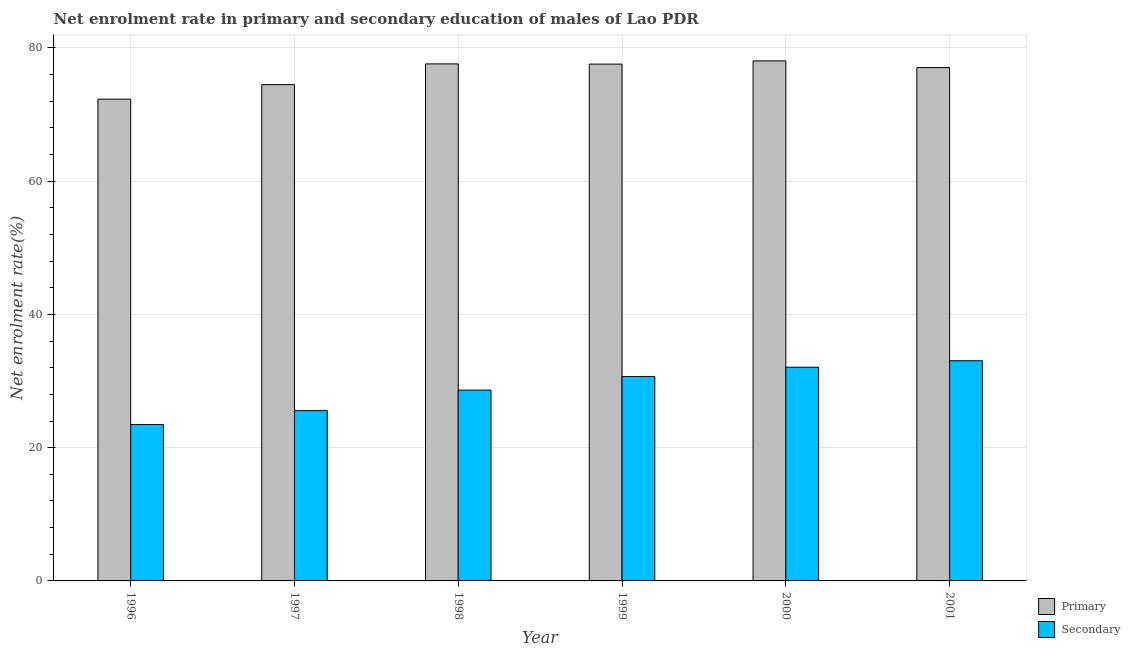Are the number of bars on each tick of the X-axis equal?
Keep it short and to the point. Yes. How many bars are there on the 4th tick from the right?
Your response must be concise. 2. In how many cases, is the number of bars for a given year not equal to the number of legend labels?
Make the answer very short. 0. What is the enrollment rate in primary education in 2000?
Offer a very short reply. 78.07. Across all years, what is the maximum enrollment rate in primary education?
Offer a terse response. 78.07. Across all years, what is the minimum enrollment rate in secondary education?
Provide a short and direct response. 23.48. In which year was the enrollment rate in primary education maximum?
Make the answer very short. 2000. In which year was the enrollment rate in secondary education minimum?
Keep it short and to the point. 1996. What is the total enrollment rate in secondary education in the graph?
Your response must be concise. 173.5. What is the difference between the enrollment rate in secondary education in 1997 and that in 1999?
Offer a very short reply. -5.12. What is the difference between the enrollment rate in primary education in 1998 and the enrollment rate in secondary education in 2000?
Provide a succinct answer. -0.45. What is the average enrollment rate in primary education per year?
Provide a short and direct response. 76.19. In the year 2000, what is the difference between the enrollment rate in primary education and enrollment rate in secondary education?
Your answer should be compact. 0. What is the ratio of the enrollment rate in primary education in 1998 to that in 2000?
Your response must be concise. 0.99. Is the difference between the enrollment rate in primary education in 1996 and 1997 greater than the difference between the enrollment rate in secondary education in 1996 and 1997?
Provide a short and direct response. No. What is the difference between the highest and the second highest enrollment rate in primary education?
Offer a very short reply. 0.45. What is the difference between the highest and the lowest enrollment rate in secondary education?
Your answer should be very brief. 9.57. What does the 2nd bar from the left in 2000 represents?
Provide a short and direct response. Secondary. What does the 1st bar from the right in 1997 represents?
Your response must be concise. Secondary. How many bars are there?
Keep it short and to the point. 12. Are all the bars in the graph horizontal?
Keep it short and to the point. No. How many years are there in the graph?
Offer a very short reply. 6. What is the difference between two consecutive major ticks on the Y-axis?
Provide a short and direct response. 20. Does the graph contain any zero values?
Your answer should be very brief. No. Where does the legend appear in the graph?
Offer a terse response. Bottom right. How many legend labels are there?
Give a very brief answer. 2. What is the title of the graph?
Your response must be concise. Net enrolment rate in primary and secondary education of males of Lao PDR. What is the label or title of the X-axis?
Offer a very short reply. Year. What is the label or title of the Y-axis?
Your answer should be very brief. Net enrolment rate(%). What is the Net enrolment rate(%) in Primary in 1996?
Your answer should be very brief. 72.32. What is the Net enrolment rate(%) in Secondary in 1996?
Make the answer very short. 23.48. What is the Net enrolment rate(%) in Primary in 1997?
Provide a succinct answer. 74.5. What is the Net enrolment rate(%) of Secondary in 1997?
Make the answer very short. 25.56. What is the Net enrolment rate(%) in Primary in 1998?
Keep it short and to the point. 77.61. What is the Net enrolment rate(%) of Secondary in 1998?
Offer a terse response. 28.64. What is the Net enrolment rate(%) in Primary in 1999?
Your answer should be compact. 77.58. What is the Net enrolment rate(%) in Secondary in 1999?
Provide a short and direct response. 30.68. What is the Net enrolment rate(%) of Primary in 2000?
Keep it short and to the point. 78.07. What is the Net enrolment rate(%) of Secondary in 2000?
Your response must be concise. 32.08. What is the Net enrolment rate(%) of Primary in 2001?
Provide a short and direct response. 77.06. What is the Net enrolment rate(%) of Secondary in 2001?
Offer a very short reply. 33.05. Across all years, what is the maximum Net enrolment rate(%) in Primary?
Ensure brevity in your answer.  78.07. Across all years, what is the maximum Net enrolment rate(%) of Secondary?
Your answer should be very brief. 33.05. Across all years, what is the minimum Net enrolment rate(%) in Primary?
Provide a succinct answer. 72.32. Across all years, what is the minimum Net enrolment rate(%) in Secondary?
Make the answer very short. 23.48. What is the total Net enrolment rate(%) of Primary in the graph?
Offer a terse response. 457.14. What is the total Net enrolment rate(%) in Secondary in the graph?
Give a very brief answer. 173.5. What is the difference between the Net enrolment rate(%) of Primary in 1996 and that in 1997?
Your answer should be compact. -2.18. What is the difference between the Net enrolment rate(%) of Secondary in 1996 and that in 1997?
Your response must be concise. -2.08. What is the difference between the Net enrolment rate(%) of Primary in 1996 and that in 1998?
Provide a short and direct response. -5.29. What is the difference between the Net enrolment rate(%) of Secondary in 1996 and that in 1998?
Give a very brief answer. -5.16. What is the difference between the Net enrolment rate(%) of Primary in 1996 and that in 1999?
Your answer should be compact. -5.26. What is the difference between the Net enrolment rate(%) in Secondary in 1996 and that in 1999?
Offer a terse response. -7.2. What is the difference between the Net enrolment rate(%) of Primary in 1996 and that in 2000?
Ensure brevity in your answer.  -5.75. What is the difference between the Net enrolment rate(%) in Secondary in 1996 and that in 2000?
Your response must be concise. -8.6. What is the difference between the Net enrolment rate(%) in Primary in 1996 and that in 2001?
Your response must be concise. -4.74. What is the difference between the Net enrolment rate(%) in Secondary in 1996 and that in 2001?
Offer a very short reply. -9.57. What is the difference between the Net enrolment rate(%) of Primary in 1997 and that in 1998?
Provide a succinct answer. -3.11. What is the difference between the Net enrolment rate(%) of Secondary in 1997 and that in 1998?
Your answer should be compact. -3.08. What is the difference between the Net enrolment rate(%) in Primary in 1997 and that in 1999?
Provide a succinct answer. -3.08. What is the difference between the Net enrolment rate(%) of Secondary in 1997 and that in 1999?
Offer a terse response. -5.12. What is the difference between the Net enrolment rate(%) in Primary in 1997 and that in 2000?
Provide a succinct answer. -3.56. What is the difference between the Net enrolment rate(%) in Secondary in 1997 and that in 2000?
Offer a very short reply. -6.52. What is the difference between the Net enrolment rate(%) in Primary in 1997 and that in 2001?
Your answer should be compact. -2.56. What is the difference between the Net enrolment rate(%) in Secondary in 1997 and that in 2001?
Keep it short and to the point. -7.49. What is the difference between the Net enrolment rate(%) of Primary in 1998 and that in 1999?
Offer a very short reply. 0.03. What is the difference between the Net enrolment rate(%) of Secondary in 1998 and that in 1999?
Your answer should be very brief. -2.04. What is the difference between the Net enrolment rate(%) in Primary in 1998 and that in 2000?
Ensure brevity in your answer.  -0.45. What is the difference between the Net enrolment rate(%) of Secondary in 1998 and that in 2000?
Ensure brevity in your answer.  -3.44. What is the difference between the Net enrolment rate(%) of Primary in 1998 and that in 2001?
Ensure brevity in your answer.  0.55. What is the difference between the Net enrolment rate(%) of Secondary in 1998 and that in 2001?
Give a very brief answer. -4.41. What is the difference between the Net enrolment rate(%) in Primary in 1999 and that in 2000?
Your answer should be very brief. -0.48. What is the difference between the Net enrolment rate(%) in Secondary in 1999 and that in 2000?
Your answer should be very brief. -1.4. What is the difference between the Net enrolment rate(%) of Primary in 1999 and that in 2001?
Provide a short and direct response. 0.52. What is the difference between the Net enrolment rate(%) in Secondary in 1999 and that in 2001?
Your answer should be compact. -2.37. What is the difference between the Net enrolment rate(%) of Primary in 2000 and that in 2001?
Keep it short and to the point. 1.01. What is the difference between the Net enrolment rate(%) in Secondary in 2000 and that in 2001?
Your answer should be very brief. -0.97. What is the difference between the Net enrolment rate(%) in Primary in 1996 and the Net enrolment rate(%) in Secondary in 1997?
Offer a very short reply. 46.76. What is the difference between the Net enrolment rate(%) of Primary in 1996 and the Net enrolment rate(%) of Secondary in 1998?
Keep it short and to the point. 43.68. What is the difference between the Net enrolment rate(%) in Primary in 1996 and the Net enrolment rate(%) in Secondary in 1999?
Ensure brevity in your answer.  41.64. What is the difference between the Net enrolment rate(%) in Primary in 1996 and the Net enrolment rate(%) in Secondary in 2000?
Give a very brief answer. 40.24. What is the difference between the Net enrolment rate(%) in Primary in 1996 and the Net enrolment rate(%) in Secondary in 2001?
Give a very brief answer. 39.27. What is the difference between the Net enrolment rate(%) of Primary in 1997 and the Net enrolment rate(%) of Secondary in 1998?
Your answer should be compact. 45.86. What is the difference between the Net enrolment rate(%) of Primary in 1997 and the Net enrolment rate(%) of Secondary in 1999?
Offer a terse response. 43.82. What is the difference between the Net enrolment rate(%) of Primary in 1997 and the Net enrolment rate(%) of Secondary in 2000?
Your response must be concise. 42.42. What is the difference between the Net enrolment rate(%) of Primary in 1997 and the Net enrolment rate(%) of Secondary in 2001?
Provide a short and direct response. 41.45. What is the difference between the Net enrolment rate(%) in Primary in 1998 and the Net enrolment rate(%) in Secondary in 1999?
Offer a very short reply. 46.93. What is the difference between the Net enrolment rate(%) of Primary in 1998 and the Net enrolment rate(%) of Secondary in 2000?
Keep it short and to the point. 45.53. What is the difference between the Net enrolment rate(%) of Primary in 1998 and the Net enrolment rate(%) of Secondary in 2001?
Offer a terse response. 44.56. What is the difference between the Net enrolment rate(%) of Primary in 1999 and the Net enrolment rate(%) of Secondary in 2000?
Keep it short and to the point. 45.5. What is the difference between the Net enrolment rate(%) in Primary in 1999 and the Net enrolment rate(%) in Secondary in 2001?
Offer a terse response. 44.53. What is the difference between the Net enrolment rate(%) of Primary in 2000 and the Net enrolment rate(%) of Secondary in 2001?
Ensure brevity in your answer.  45.01. What is the average Net enrolment rate(%) of Primary per year?
Your answer should be compact. 76.19. What is the average Net enrolment rate(%) of Secondary per year?
Your answer should be compact. 28.92. In the year 1996, what is the difference between the Net enrolment rate(%) of Primary and Net enrolment rate(%) of Secondary?
Offer a terse response. 48.84. In the year 1997, what is the difference between the Net enrolment rate(%) of Primary and Net enrolment rate(%) of Secondary?
Offer a terse response. 48.94. In the year 1998, what is the difference between the Net enrolment rate(%) in Primary and Net enrolment rate(%) in Secondary?
Your answer should be very brief. 48.97. In the year 1999, what is the difference between the Net enrolment rate(%) in Primary and Net enrolment rate(%) in Secondary?
Give a very brief answer. 46.9. In the year 2000, what is the difference between the Net enrolment rate(%) of Primary and Net enrolment rate(%) of Secondary?
Provide a succinct answer. 45.98. In the year 2001, what is the difference between the Net enrolment rate(%) in Primary and Net enrolment rate(%) in Secondary?
Offer a very short reply. 44.01. What is the ratio of the Net enrolment rate(%) in Primary in 1996 to that in 1997?
Your answer should be compact. 0.97. What is the ratio of the Net enrolment rate(%) in Secondary in 1996 to that in 1997?
Your answer should be very brief. 0.92. What is the ratio of the Net enrolment rate(%) of Primary in 1996 to that in 1998?
Offer a terse response. 0.93. What is the ratio of the Net enrolment rate(%) in Secondary in 1996 to that in 1998?
Offer a terse response. 0.82. What is the ratio of the Net enrolment rate(%) of Primary in 1996 to that in 1999?
Offer a very short reply. 0.93. What is the ratio of the Net enrolment rate(%) in Secondary in 1996 to that in 1999?
Provide a short and direct response. 0.77. What is the ratio of the Net enrolment rate(%) of Primary in 1996 to that in 2000?
Ensure brevity in your answer.  0.93. What is the ratio of the Net enrolment rate(%) of Secondary in 1996 to that in 2000?
Your response must be concise. 0.73. What is the ratio of the Net enrolment rate(%) of Primary in 1996 to that in 2001?
Offer a terse response. 0.94. What is the ratio of the Net enrolment rate(%) of Secondary in 1996 to that in 2001?
Your response must be concise. 0.71. What is the ratio of the Net enrolment rate(%) of Primary in 1997 to that in 1998?
Give a very brief answer. 0.96. What is the ratio of the Net enrolment rate(%) of Secondary in 1997 to that in 1998?
Provide a short and direct response. 0.89. What is the ratio of the Net enrolment rate(%) in Primary in 1997 to that in 1999?
Give a very brief answer. 0.96. What is the ratio of the Net enrolment rate(%) of Secondary in 1997 to that in 1999?
Your response must be concise. 0.83. What is the ratio of the Net enrolment rate(%) of Primary in 1997 to that in 2000?
Your response must be concise. 0.95. What is the ratio of the Net enrolment rate(%) of Secondary in 1997 to that in 2000?
Offer a very short reply. 0.8. What is the ratio of the Net enrolment rate(%) of Primary in 1997 to that in 2001?
Offer a terse response. 0.97. What is the ratio of the Net enrolment rate(%) of Secondary in 1997 to that in 2001?
Your response must be concise. 0.77. What is the ratio of the Net enrolment rate(%) in Secondary in 1998 to that in 1999?
Make the answer very short. 0.93. What is the ratio of the Net enrolment rate(%) of Secondary in 1998 to that in 2000?
Provide a short and direct response. 0.89. What is the ratio of the Net enrolment rate(%) in Secondary in 1998 to that in 2001?
Ensure brevity in your answer.  0.87. What is the ratio of the Net enrolment rate(%) of Primary in 1999 to that in 2000?
Provide a succinct answer. 0.99. What is the ratio of the Net enrolment rate(%) of Secondary in 1999 to that in 2000?
Provide a succinct answer. 0.96. What is the ratio of the Net enrolment rate(%) of Primary in 1999 to that in 2001?
Your answer should be very brief. 1.01. What is the ratio of the Net enrolment rate(%) in Secondary in 1999 to that in 2001?
Give a very brief answer. 0.93. What is the ratio of the Net enrolment rate(%) in Primary in 2000 to that in 2001?
Your response must be concise. 1.01. What is the ratio of the Net enrolment rate(%) in Secondary in 2000 to that in 2001?
Provide a short and direct response. 0.97. What is the difference between the highest and the second highest Net enrolment rate(%) in Primary?
Offer a very short reply. 0.45. What is the difference between the highest and the second highest Net enrolment rate(%) of Secondary?
Your response must be concise. 0.97. What is the difference between the highest and the lowest Net enrolment rate(%) of Primary?
Your response must be concise. 5.75. What is the difference between the highest and the lowest Net enrolment rate(%) in Secondary?
Ensure brevity in your answer.  9.57. 